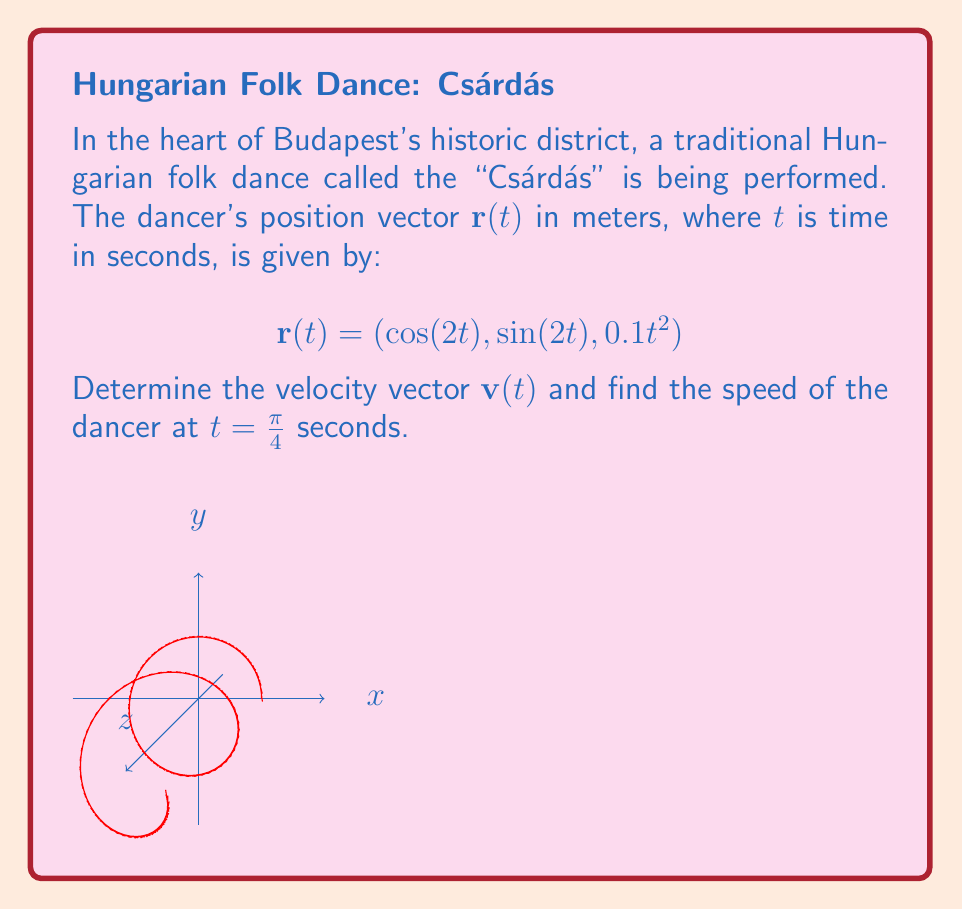Can you solve this math problem? To solve this problem, we'll follow these steps:

1) The velocity vector $\mathbf{v}(t)$ is the derivative of the position vector $\mathbf{r}(t)$ with respect to time. Let's calculate each component:

   $$\mathbf{v}(t) = \frac{d}{dt}\mathbf{r}(t) = (\frac{d}{dt}\cos(2t), \frac{d}{dt}\sin(2t), \frac{d}{dt}0.1t^2)$$

2) Applying the chain rule and power rule:

   $$\mathbf{v}(t) = (-2\sin(2t), 2\cos(2t), 0.2t)$$

3) To find the speed at $t = \frac{\pi}{4}$, we need to calculate the magnitude of the velocity vector at this time:

   $$\mathbf{v}(\frac{\pi}{4}) = (-2\sin(\frac{\pi}{2}), 2\cos(\frac{\pi}{2}), 0.2\frac{\pi}{4})$$

4) Simplify:

   $$\mathbf{v}(\frac{\pi}{4}) = (-2, 0, 0.05\pi)$$

5) The speed is the magnitude of the velocity vector:

   $$\text{speed} = \|\mathbf{v}(\frac{\pi}{4})\| = \sqrt{(-2)^2 + 0^2 + (0.05\pi)^2}$$

6) Calculate:

   $$\text{speed} = \sqrt{4 + 0.0025\pi^2} \approx 2.0123 \text{ m/s}$$
Answer: $2.0123 \text{ m/s}$ 